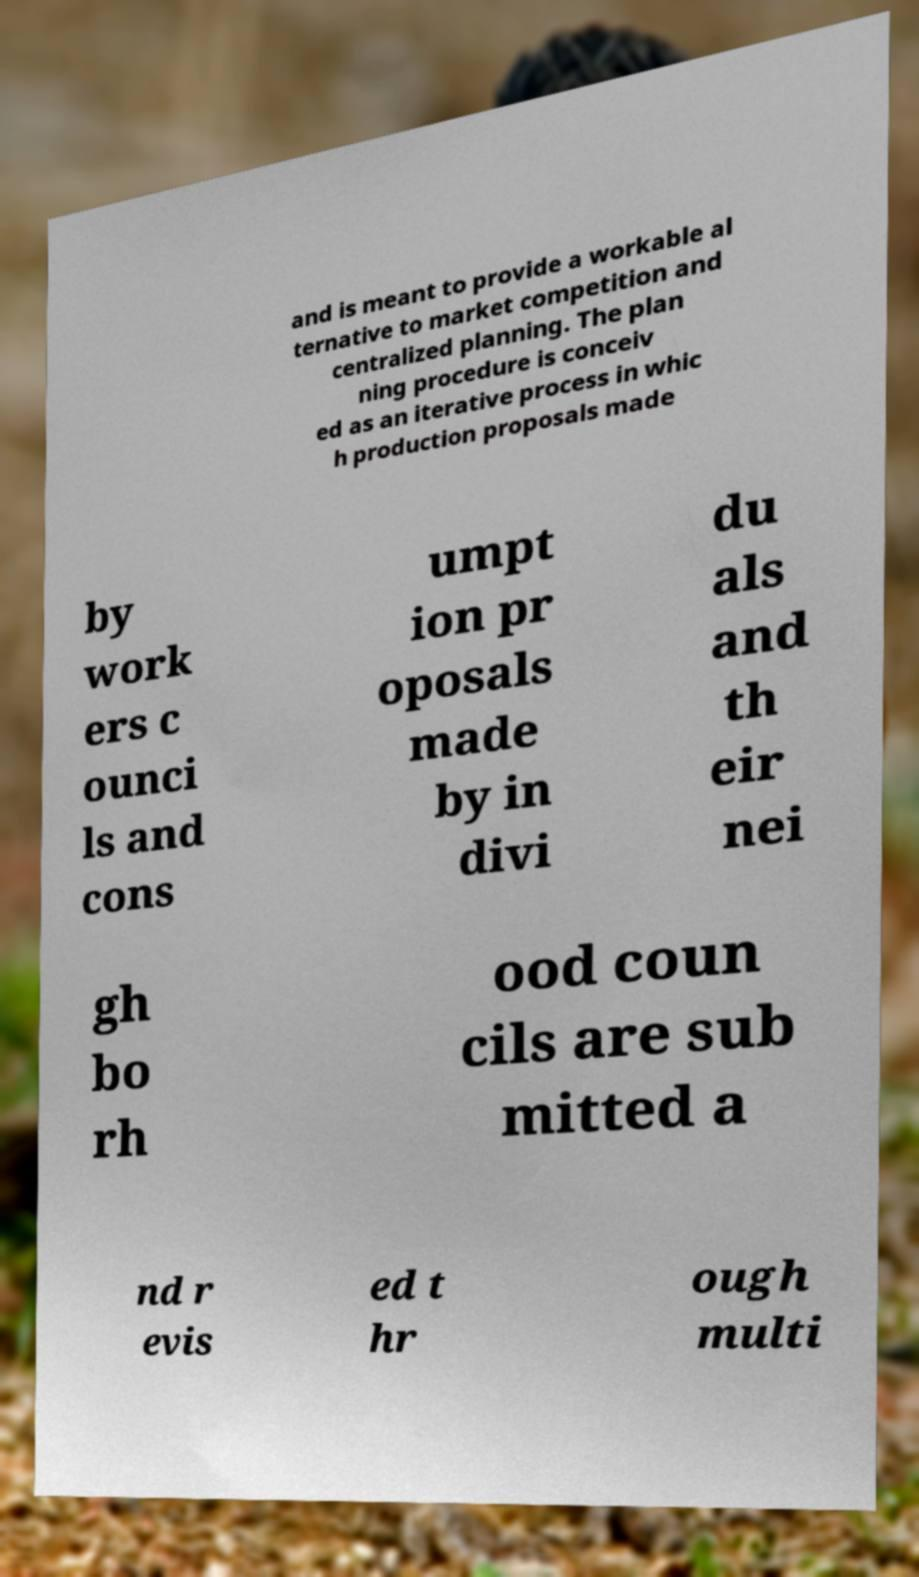What messages or text are displayed in this image? I need them in a readable, typed format. and is meant to provide a workable al ternative to market competition and centralized planning. The plan ning procedure is conceiv ed as an iterative process in whic h production proposals made by work ers c ounci ls and cons umpt ion pr oposals made by in divi du als and th eir nei gh bo rh ood coun cils are sub mitted a nd r evis ed t hr ough multi 